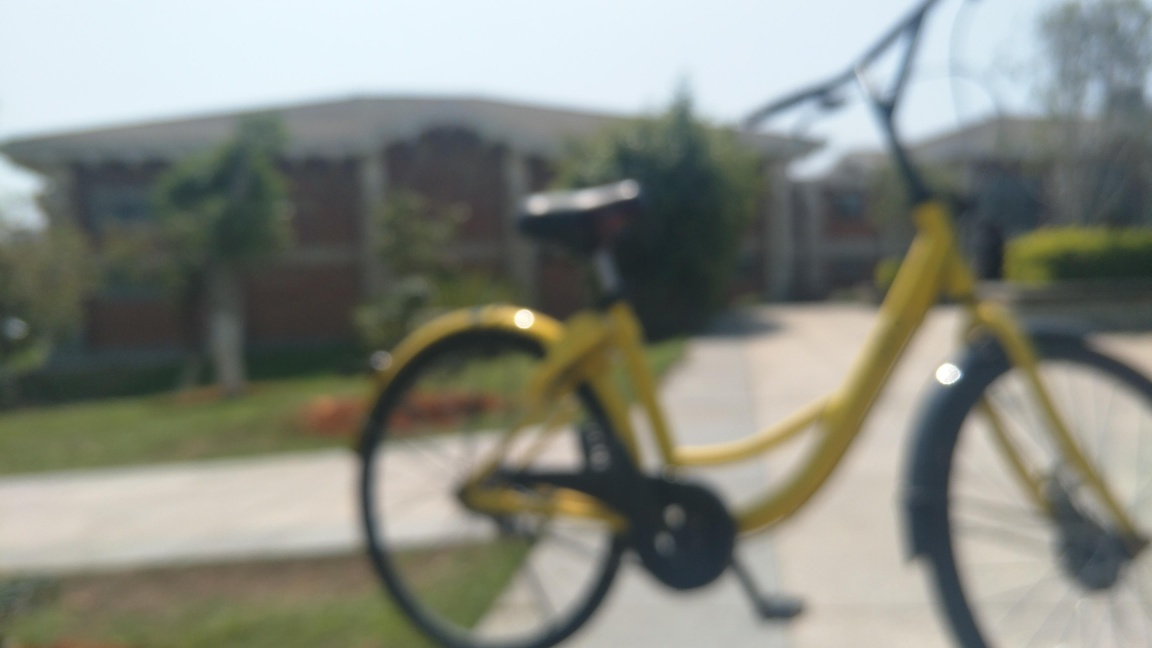What might be the reason for the blur in this image? The blur likely results from an intentional focus on a point beyond the bicycle, perhaps to create an artistic effect or due to an error in setting the camera's focus point. Can such a blur in a photograph serve a particular purpose? Certainly, a blur like this can be used artistically to draw the viewer's attention to a specific area of the image or to create a sense of mystery, depth, or movement. 